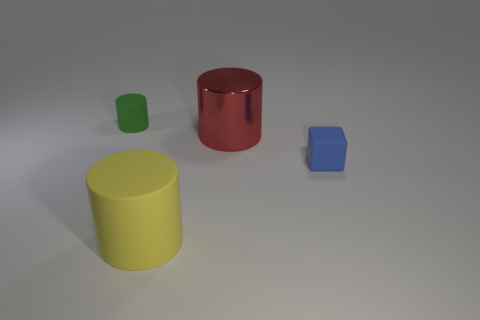Add 3 cyan objects. How many objects exist? 7 Subtract all cylinders. How many objects are left? 1 Subtract all metal cylinders. Subtract all gray blocks. How many objects are left? 3 Add 2 big shiny things. How many big shiny things are left? 3 Add 4 shiny cubes. How many shiny cubes exist? 4 Subtract 0 gray balls. How many objects are left? 4 